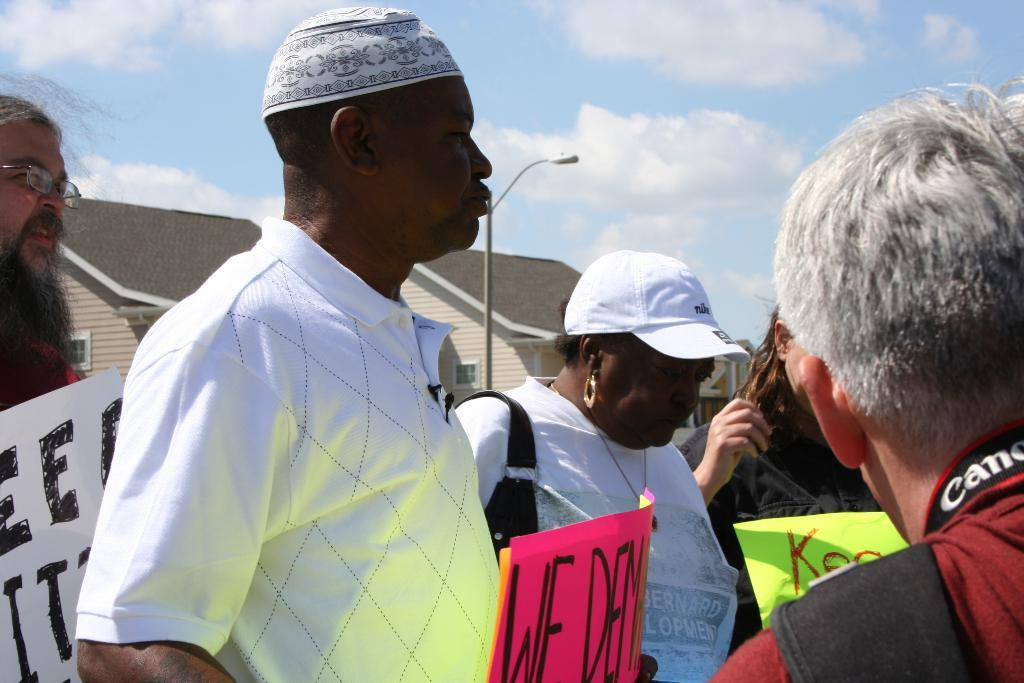What are the people in the image doing? The people in the image are standing in the center and holding banners. What can be seen in the background of the image? There is sky, clouds, buildings, and a pole visible in the background of the image. What type of muscle can be seen flexing on the banners in the image? There are no muscles visible on the banners in the image. Can you see any bubbles floating around the people in the image? There are no bubbles present in the image. 